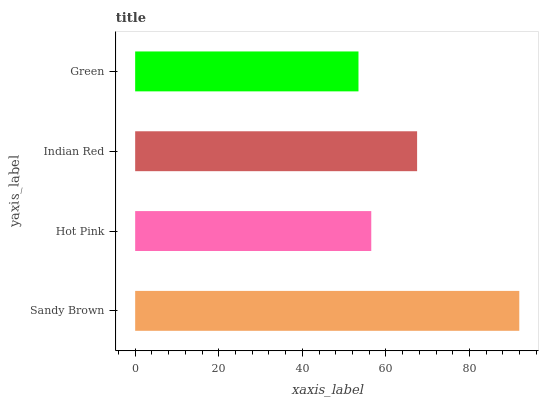Is Green the minimum?
Answer yes or no. Yes. Is Sandy Brown the maximum?
Answer yes or no. Yes. Is Hot Pink the minimum?
Answer yes or no. No. Is Hot Pink the maximum?
Answer yes or no. No. Is Sandy Brown greater than Hot Pink?
Answer yes or no. Yes. Is Hot Pink less than Sandy Brown?
Answer yes or no. Yes. Is Hot Pink greater than Sandy Brown?
Answer yes or no. No. Is Sandy Brown less than Hot Pink?
Answer yes or no. No. Is Indian Red the high median?
Answer yes or no. Yes. Is Hot Pink the low median?
Answer yes or no. Yes. Is Hot Pink the high median?
Answer yes or no. No. Is Sandy Brown the low median?
Answer yes or no. No. 